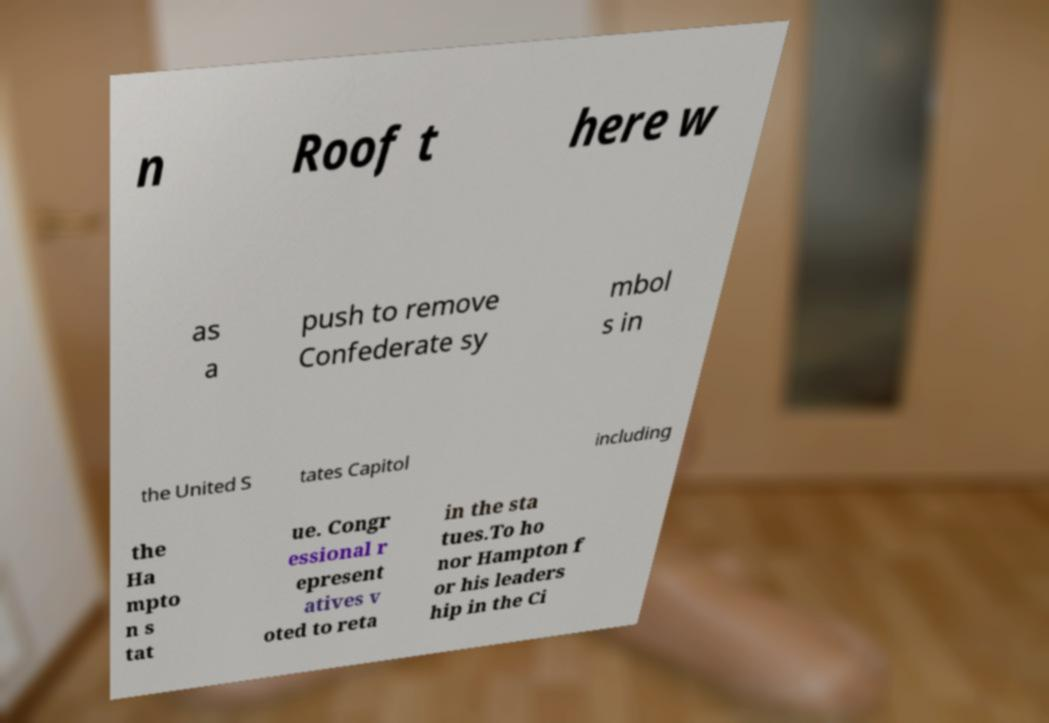Please read and relay the text visible in this image. What does it say? n Roof t here w as a push to remove Confederate sy mbol s in the United S tates Capitol including the Ha mpto n s tat ue. Congr essional r epresent atives v oted to reta in the sta tues.To ho nor Hampton f or his leaders hip in the Ci 